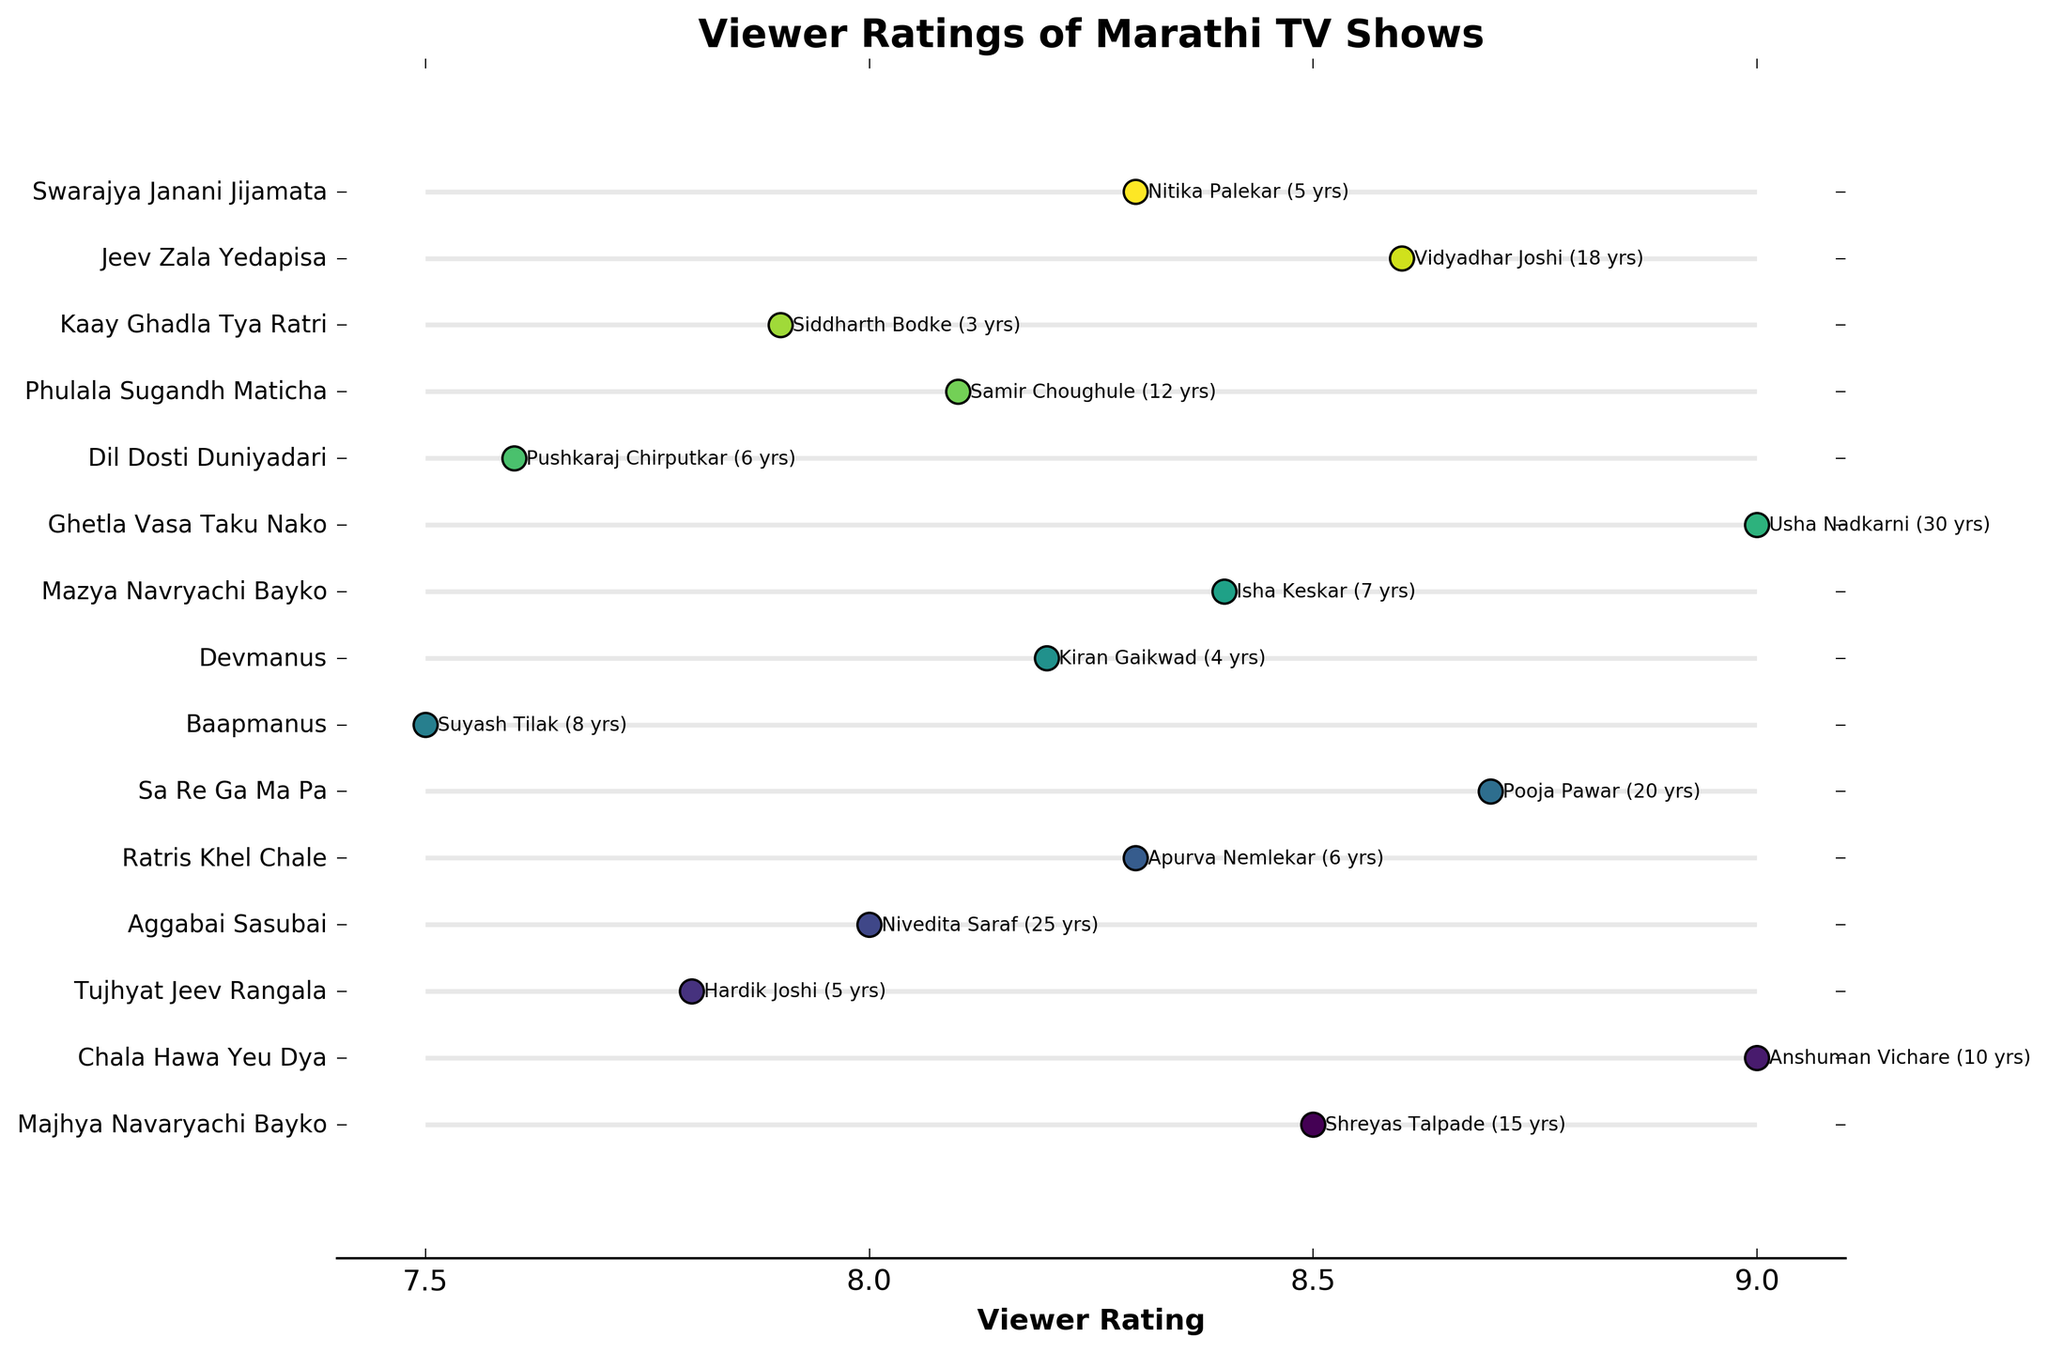What is the title of the plot? The title of the plot is displayed at the top of the figure. It is "Viewer Ratings of Marathi TV Shows".
Answer: Viewer Ratings of Marathi TV Shows How many TV shows have viewer ratings above 8.0? By looking at the positions of the dots and their corresponding viewer ratings, we can see which ones are above 8.0. There are 11 shows above 8.0.
Answer: 11 Who has the highest viewer rating and what is the rating? The highest dot on the plot at a vertical position of 9.0 corresponds to Anshuman Vichare and Usha Nadkarni. Their ratings are both 9.0.
Answer: Anshuman Vichare and Usha Nadkarni, 9.0 Which actor has the least years of experience? What is their viewer rating? The vertical positions marked by annotations indicate the years of experience. The actor with the lowest years of experience is Siddharth Bodke with 3 years and their viewer rating is 7.9.
Answer: Siddharth Bodke, 7.9 What is the rating difference between 'Ghetla Vasa Taku Nako' and 'Sa Re Ga Ma Pa' TV shows? "Ghetla Vasa Taku Nako" has a viewer rating of 9.0 and "Sa Re Ga Ma Pa" has a viewer rating of 8.7. The difference is calculated as 9.0 - 8.7 = 0.3.
Answer: 0.3 Which show featuring an actor with 6 years of experience has the higher rating? The plot features two shows with actors having 6 years of experience: "Ratris Khel Chale" (8.3) and "Dil Dosti Duniyadari" (7.6). "Ratris Khel Chale" has the higher rating.
Answer: Ratris Khel Chale How many actors have more than 10 years of experience? Counting the actors based on their annotated years of experience, we see that 5 actors have more than 10 years of experience.
Answer: 5 Which TV show has the highest spread in ratings? The horizontal lines connect the dots for each TV show. "Ghetla Vasa Taku Nako" spreads from 7.5 to 9.0, the largest range in ratings.
Answer: Ghetla Vasa Taku Nako 